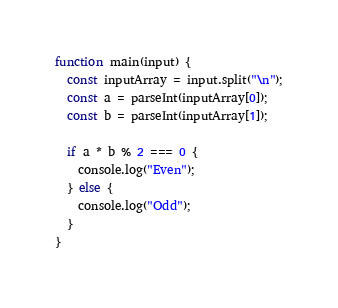Convert code to text. <code><loc_0><loc_0><loc_500><loc_500><_JavaScript_>function main(input) {
  const inputArray = input.split("\n");
  const a = parseInt(inputArray[0]);
  const b = parseInt(inputArray[1]);

  if a * b % 2 === 0 {
    console.log("Even");
  } else {
    console.log("Odd");
  }
} </code> 